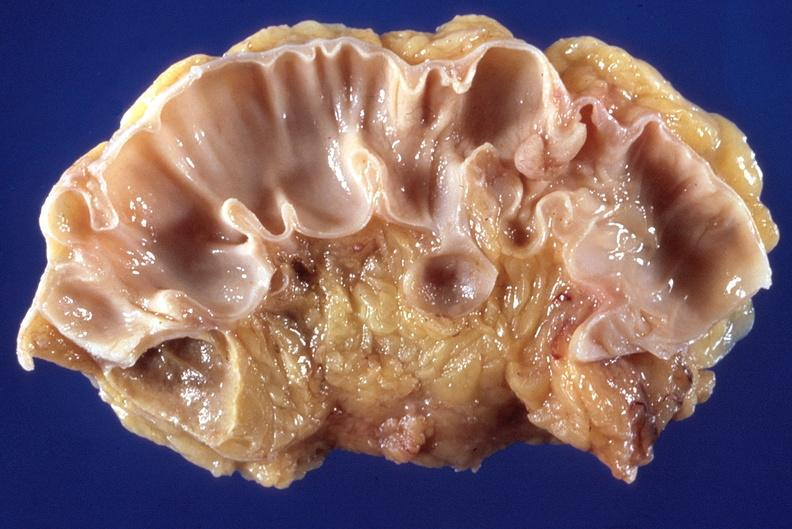where does this belong to?
Answer the question using a single word or phrase. Gastrointestinal system 